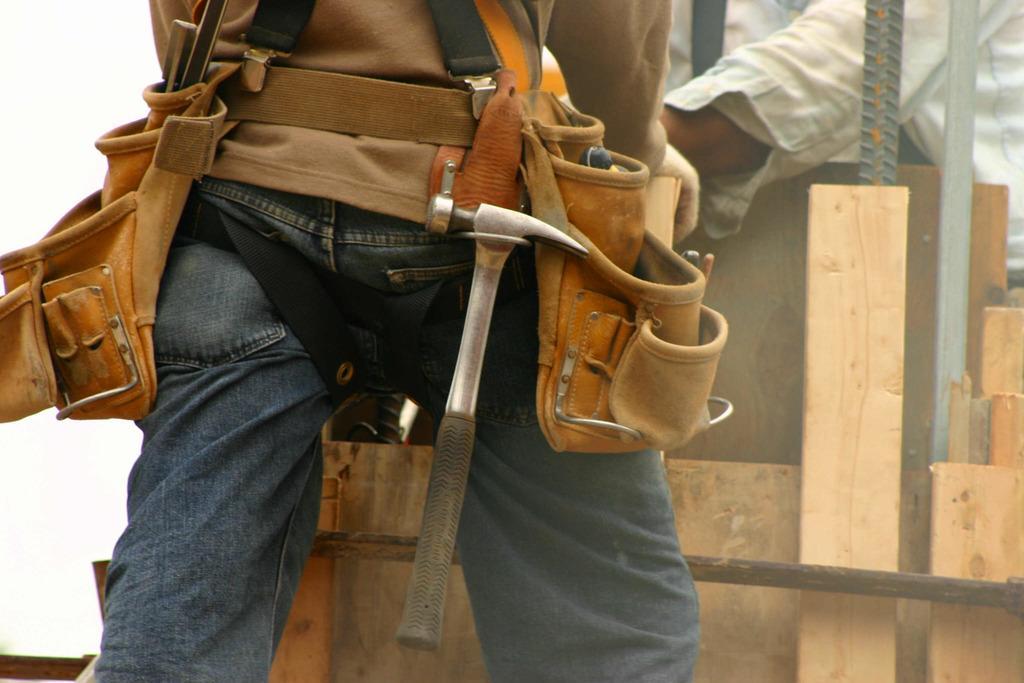In one or two sentences, can you explain what this image depicts? In this image I can see two persons, bags, metal rods, wooden sticks, hammer and wall. This image is taken may be during a day. 